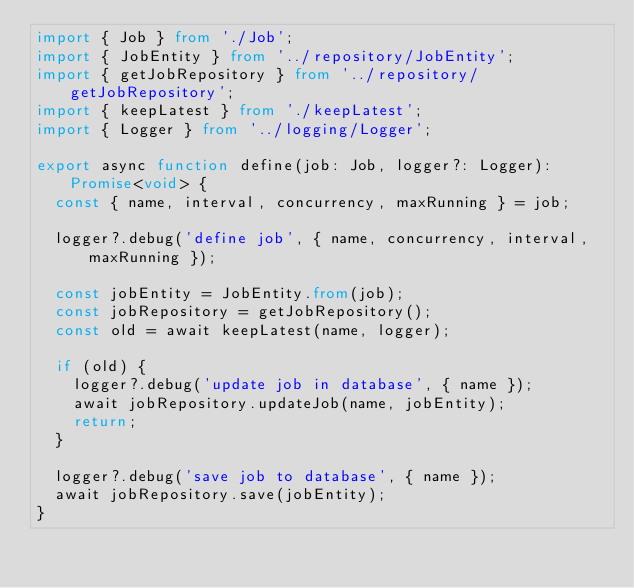<code> <loc_0><loc_0><loc_500><loc_500><_TypeScript_>import { Job } from './Job';
import { JobEntity } from '../repository/JobEntity';
import { getJobRepository } from '../repository/getJobRepository';
import { keepLatest } from './keepLatest';
import { Logger } from '../logging/Logger';

export async function define(job: Job, logger?: Logger): Promise<void> {
  const { name, interval, concurrency, maxRunning } = job;

  logger?.debug('define job', { name, concurrency, interval, maxRunning });

  const jobEntity = JobEntity.from(job);
  const jobRepository = getJobRepository();
  const old = await keepLatest(name, logger);

  if (old) {
    logger?.debug('update job in database', { name });
    await jobRepository.updateJob(name, jobEntity);
    return;
  }

  logger?.debug('save job to database', { name });
  await jobRepository.save(jobEntity);
}
</code> 